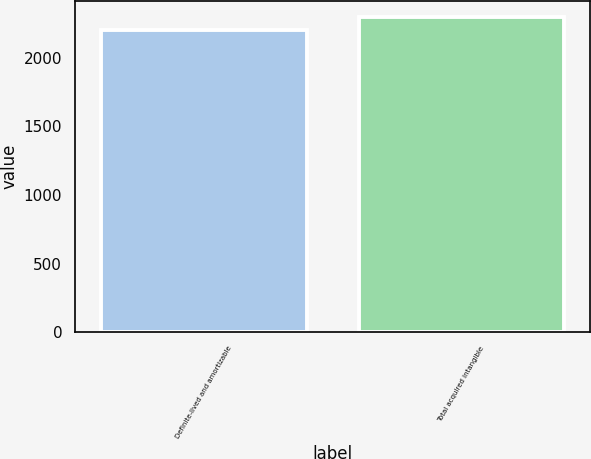Convert chart. <chart><loc_0><loc_0><loc_500><loc_500><bar_chart><fcel>Definite-lived and amortizable<fcel>Total acquired intangible<nl><fcel>2198<fcel>2298<nl></chart> 